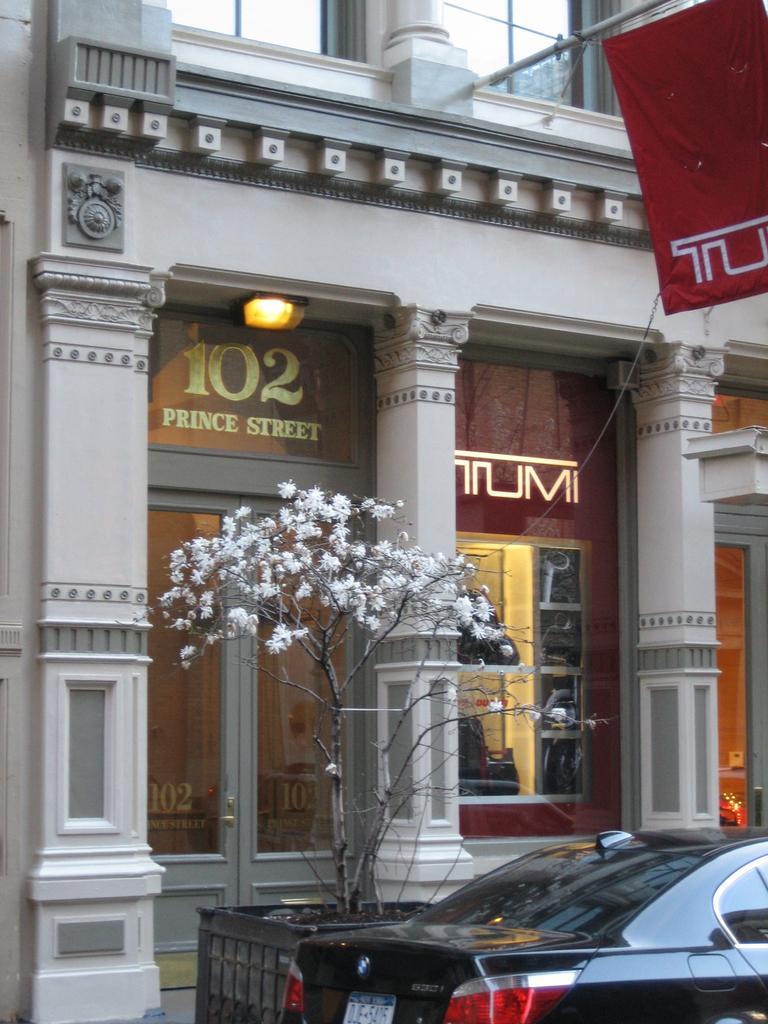In one or two sentences, can you explain what this image depicts? In this image we can see the building with the windows and also lights. We can also see the flag, tree, soil, black color pot and also the car at the bottom. 